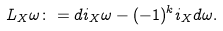Convert formula to latex. <formula><loc_0><loc_0><loc_500><loc_500>L _ { X } \omega \colon = d i _ { X } \omega - ( - 1 ) ^ { k } i _ { X } d \omega .</formula> 